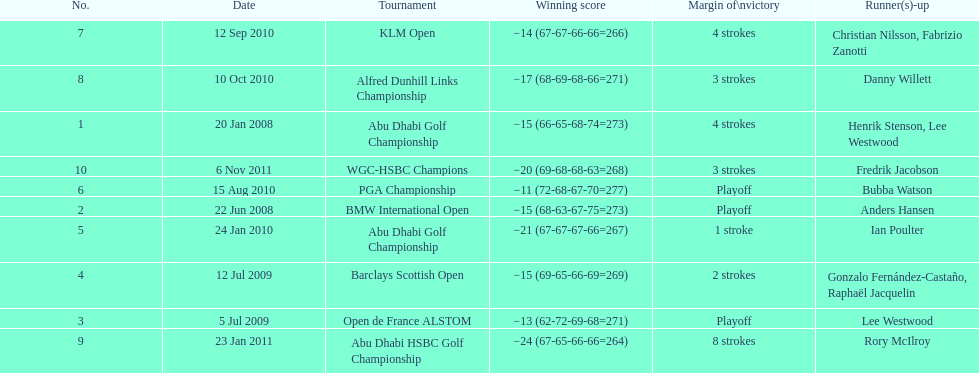What were the margins of victories of the tournaments? 4 strokes, Playoff, Playoff, 2 strokes, 1 stroke, Playoff, 4 strokes, 3 strokes, 8 strokes, 3 strokes. Of these, what was the margin of victory of the klm and the barklay 2 strokes, 4 strokes. What were the difference between these? 2 strokes. 